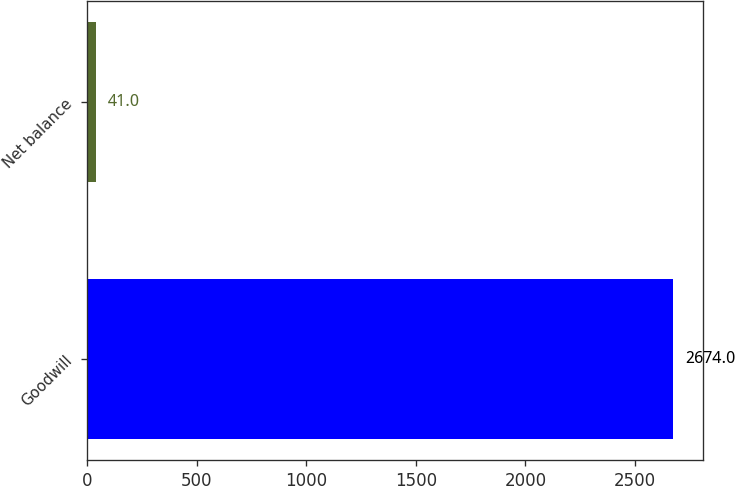Convert chart to OTSL. <chart><loc_0><loc_0><loc_500><loc_500><bar_chart><fcel>Goodwill<fcel>Net balance<nl><fcel>2674<fcel>41<nl></chart> 